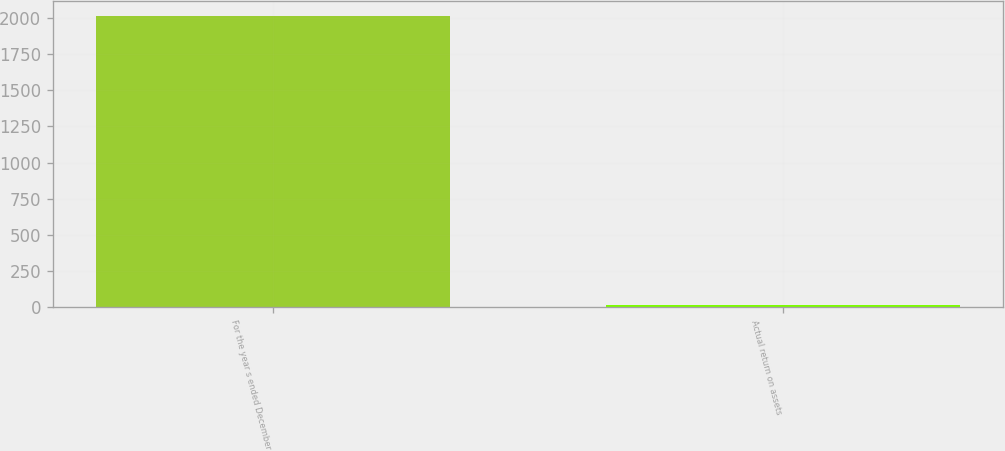<chart> <loc_0><loc_0><loc_500><loc_500><bar_chart><fcel>For the year s ended December<fcel>Actual return on assets<nl><fcel>2013<fcel>16.7<nl></chart> 